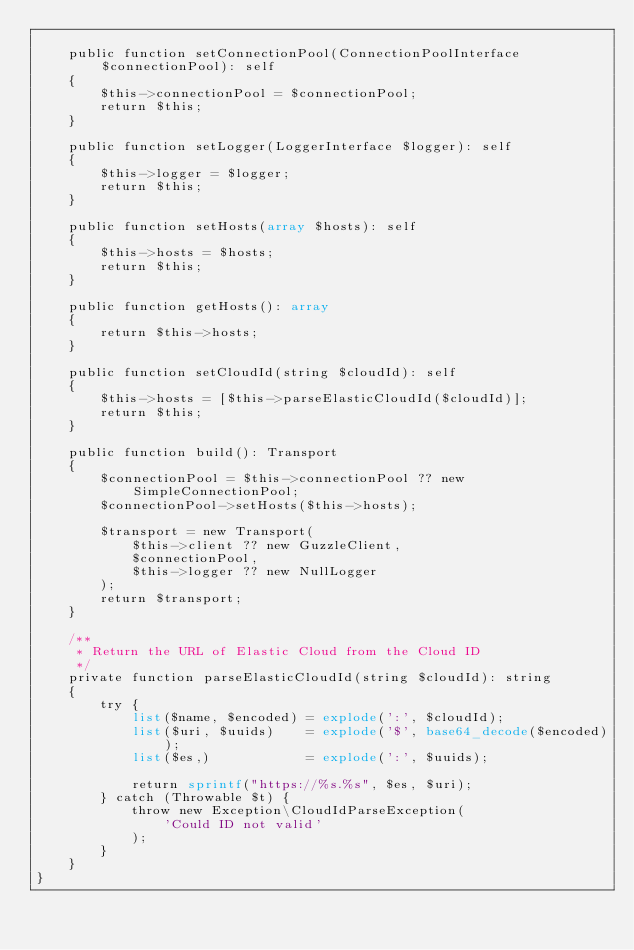Convert code to text. <code><loc_0><loc_0><loc_500><loc_500><_PHP_>
    public function setConnectionPool(ConnectionPoolInterface $connectionPool): self
    {
        $this->connectionPool = $connectionPool;
        return $this;
    }

    public function setLogger(LoggerInterface $logger): self
    {
        $this->logger = $logger;
        return $this;
    }

    public function setHosts(array $hosts): self
    {
        $this->hosts = $hosts;
        return $this;
    }

    public function getHosts(): array
    {
        return $this->hosts;
    }

    public function setCloudId(string $cloudId): self
    {
        $this->hosts = [$this->parseElasticCloudId($cloudId)];
        return $this;
    }

    public function build(): Transport
    {
        $connectionPool = $this->connectionPool ?? new SimpleConnectionPool;
        $connectionPool->setHosts($this->hosts);

        $transport = new Transport(
            $this->client ?? new GuzzleClient,
            $connectionPool,
            $this->logger ?? new NullLogger
        );
        return $transport;
    }

    /**
     * Return the URL of Elastic Cloud from the Cloud ID
     */
    private function parseElasticCloudId(string $cloudId): string
    {
        try {
            list($name, $encoded) = explode(':', $cloudId);
            list($uri, $uuids)    = explode('$', base64_decode($encoded));
            list($es,)            = explode(':', $uuids);

            return sprintf("https://%s.%s", $es, $uri);
        } catch (Throwable $t) {
            throw new Exception\CloudIdParseException(
                'Could ID not valid'
            );
        }
    }
}</code> 